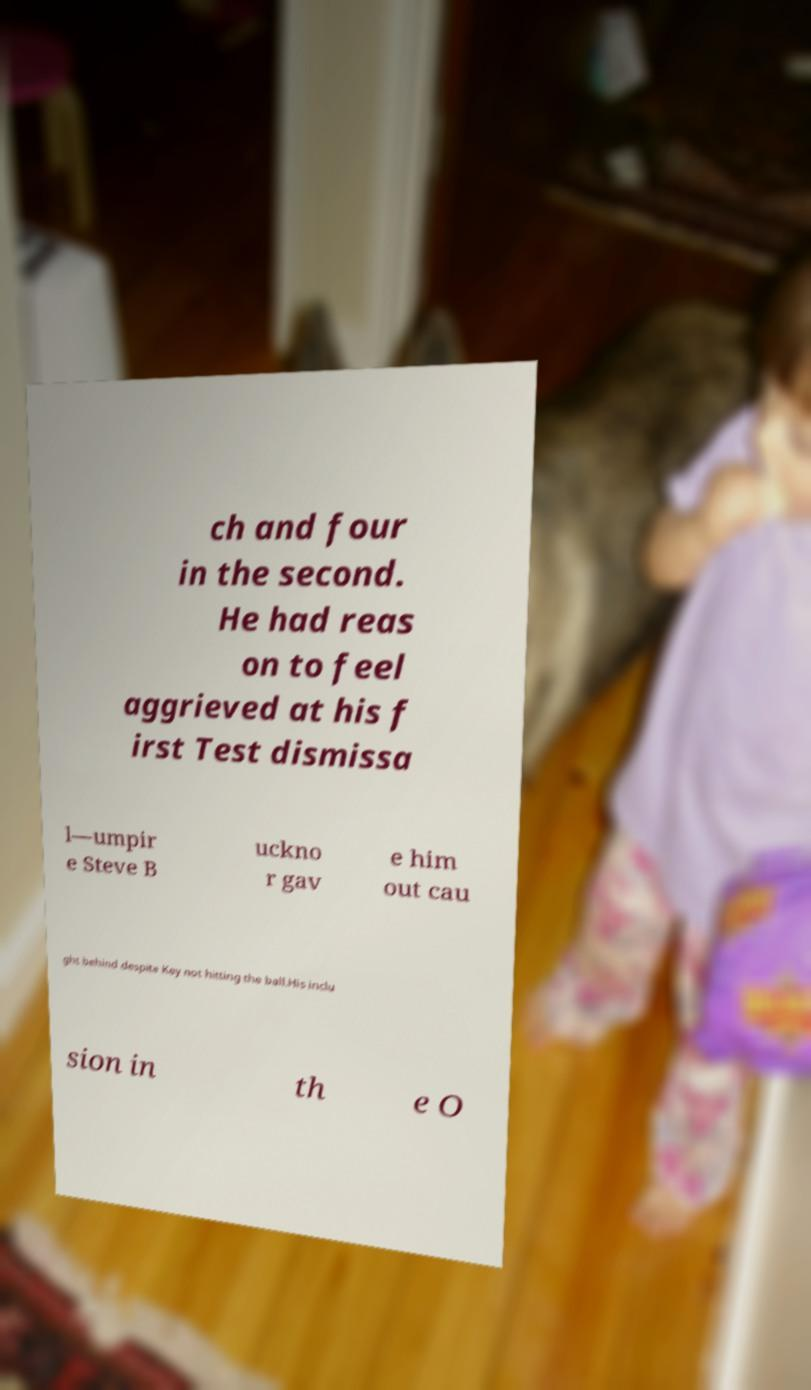Could you extract and type out the text from this image? ch and four in the second. He had reas on to feel aggrieved at his f irst Test dismissa l—umpir e Steve B uckno r gav e him out cau ght behind despite Key not hitting the ball.His inclu sion in th e O 